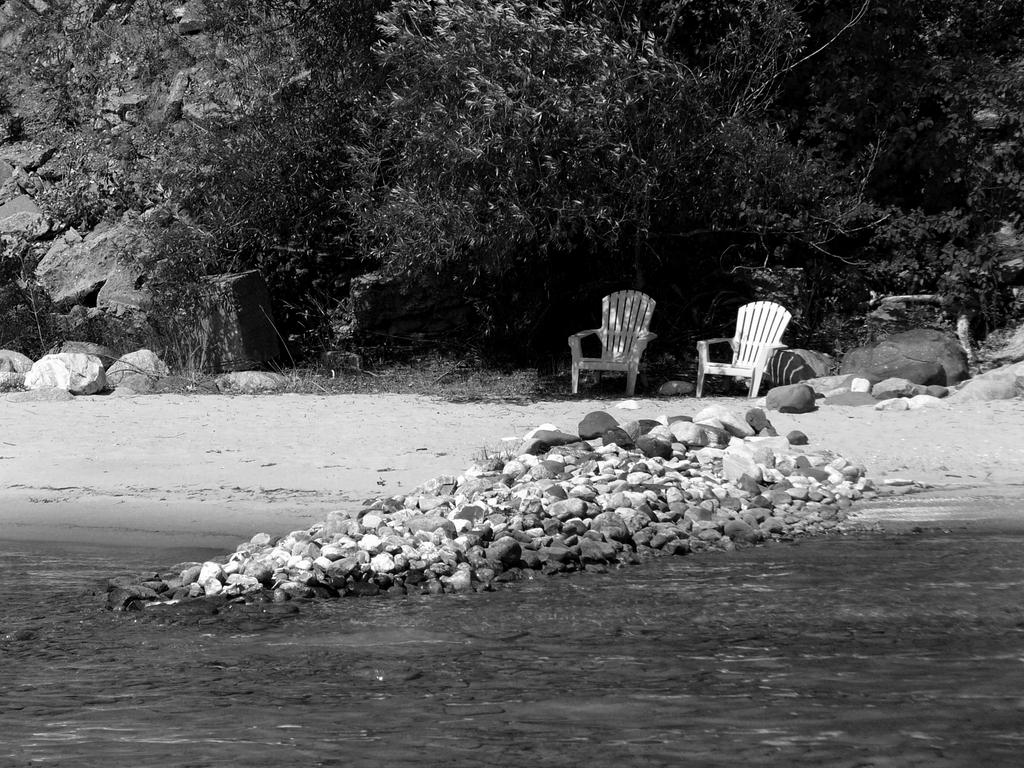What is the primary element in the image? There is water in the image. What other objects can be seen in the image? There are rocks in the image. What can be seen in the background of the image? There are chairs and trees in the background of the image. How is the image presented? The photography is in black and white. Who is the creator of the match in the image? There is no match present in the image, so it is not possible to determine the creator. 